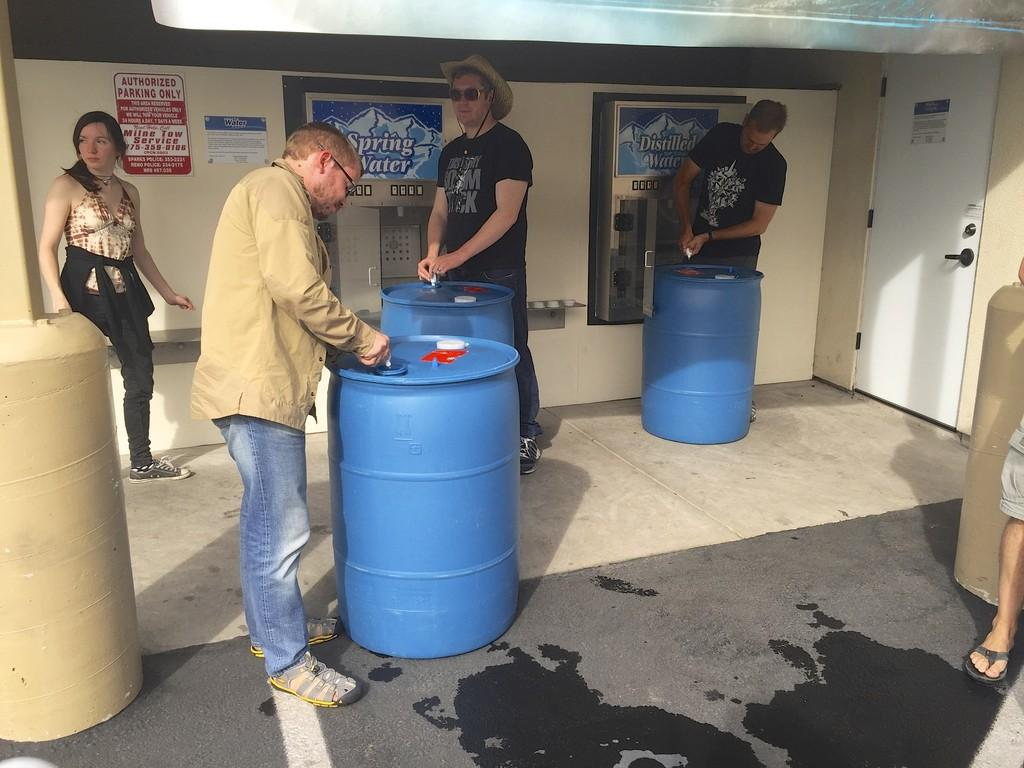<image>
Write a terse but informative summary of the picture. people filling up barrels outside of a spring water facility 